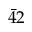Convert formula to latex. <formula><loc_0><loc_0><loc_500><loc_500>\bar { 4 } 2</formula> 